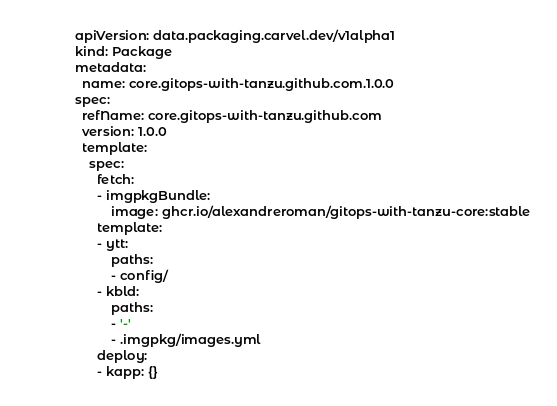Convert code to text. <code><loc_0><loc_0><loc_500><loc_500><_YAML_>apiVersion: data.packaging.carvel.dev/v1alpha1
kind: Package
metadata:
  name: core.gitops-with-tanzu.github.com.1.0.0
spec:
  refName: core.gitops-with-tanzu.github.com
  version: 1.0.0
  template:
    spec:
      fetch:
      - imgpkgBundle:
          image: ghcr.io/alexandreroman/gitops-with-tanzu-core:stable
      template:
      - ytt:
          paths:
          - config/
      - kbld:
          paths:
          - '-'
          - .imgpkg/images.yml
      deploy:
      - kapp: {}
</code> 